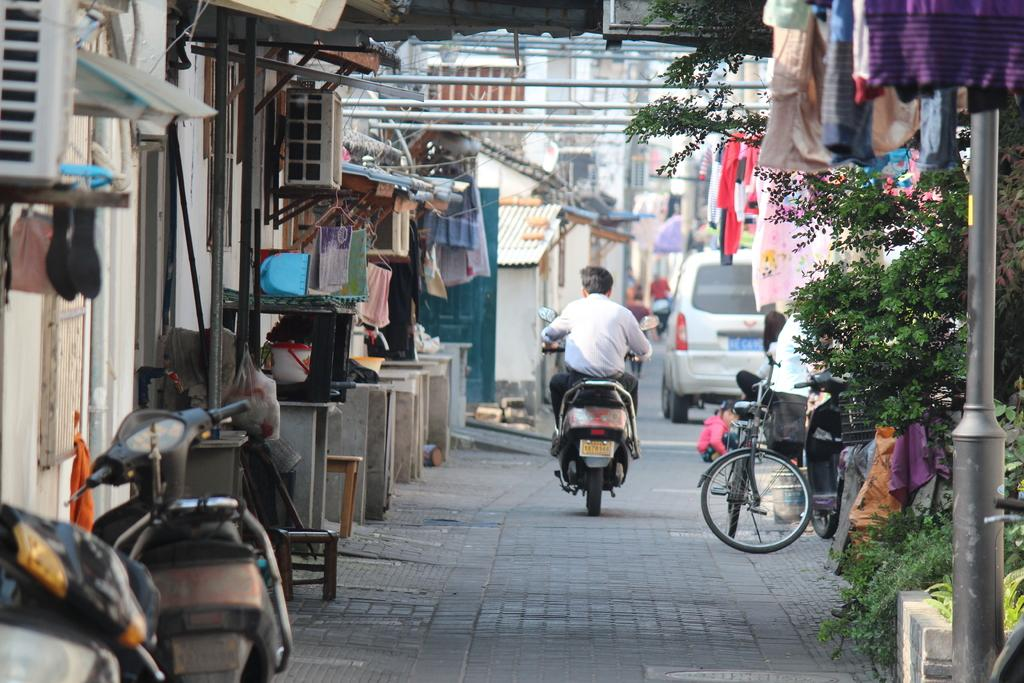What is the man in the image doing? A man is riding a bike in the image. What else can be seen in the image besides the man on the bike? There are other vehicles and a tree in the image. What else can be seen in the image? Clothes and houses are visible in the image. What type of rose can be seen in the image? There is no rose present in the image. What is the taste of the bike the man is riding? The bike is not something that can be tasted, as it is a mode of transportation and not a food item. 